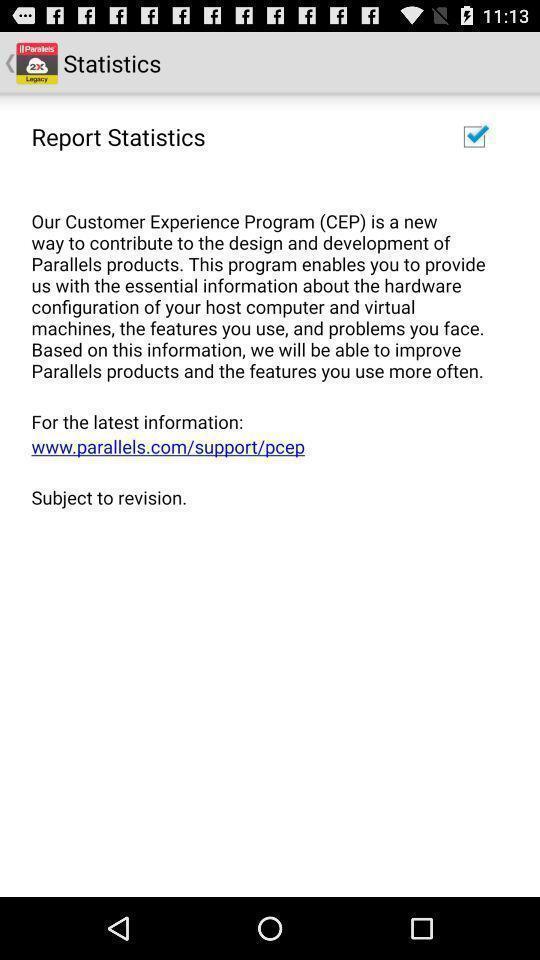What is the overall content of this screenshot? Page showing report of statistics. 